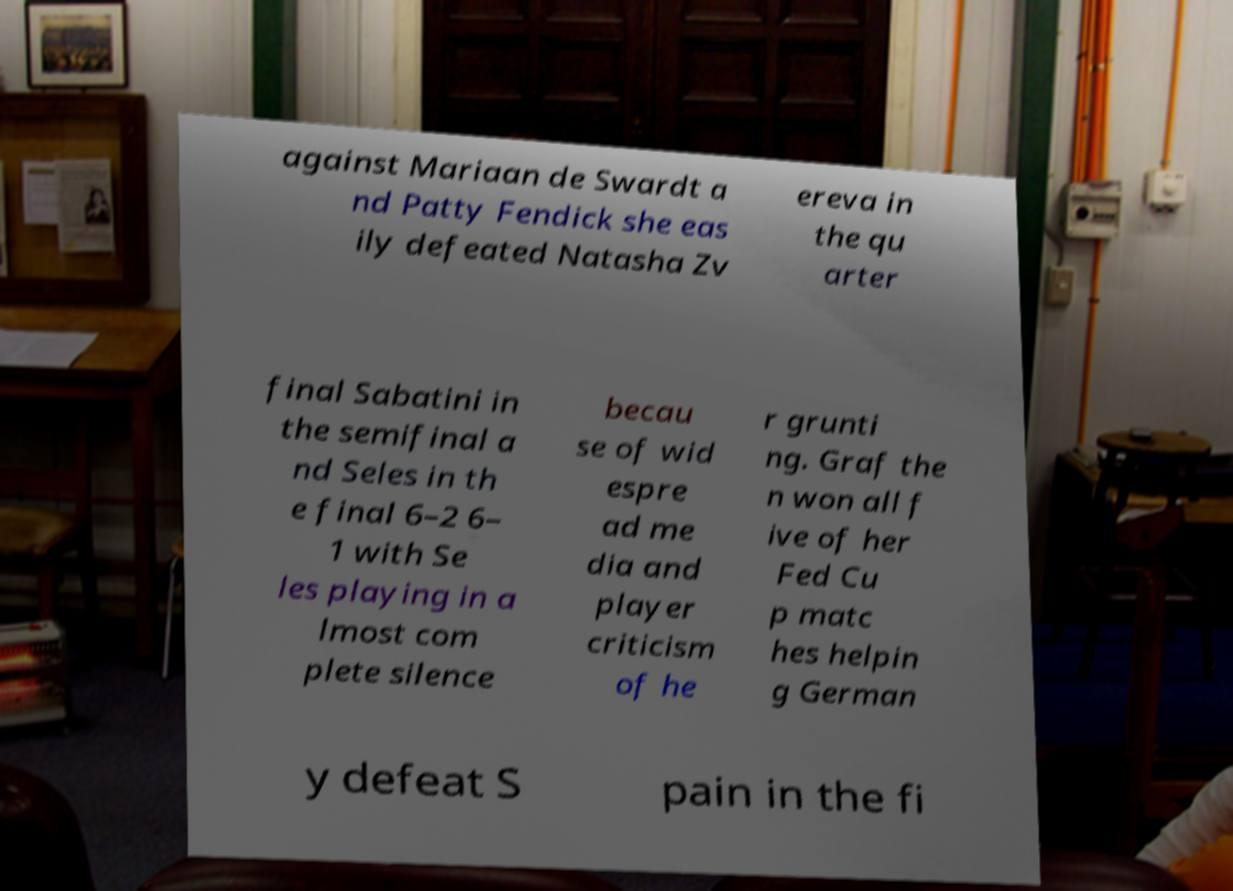Please identify and transcribe the text found in this image. against Mariaan de Swardt a nd Patty Fendick she eas ily defeated Natasha Zv ereva in the qu arter final Sabatini in the semifinal a nd Seles in th e final 6–2 6– 1 with Se les playing in a lmost com plete silence becau se of wid espre ad me dia and player criticism of he r grunti ng. Graf the n won all f ive of her Fed Cu p matc hes helpin g German y defeat S pain in the fi 